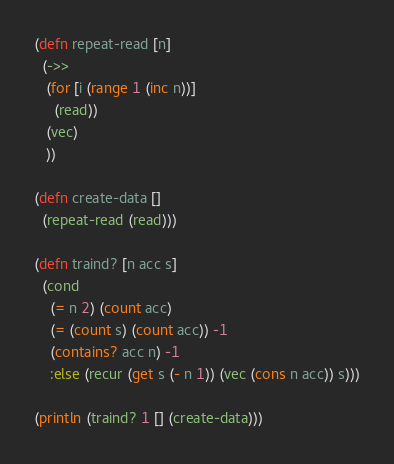<code> <loc_0><loc_0><loc_500><loc_500><_Clojure_>(defn repeat-read [n]
  (->>
   (for [i (range 1 (inc n))]
     (read))
   (vec)
   ))

(defn create-data []
  (repeat-read (read)))

(defn traind? [n acc s]
  (cond
    (= n 2) (count acc)
    (= (count s) (count acc)) -1
    (contains? acc n) -1
    :else (recur (get s (- n 1)) (vec (cons n acc)) s)))

(println (traind? 1 [] (create-data)))
</code> 